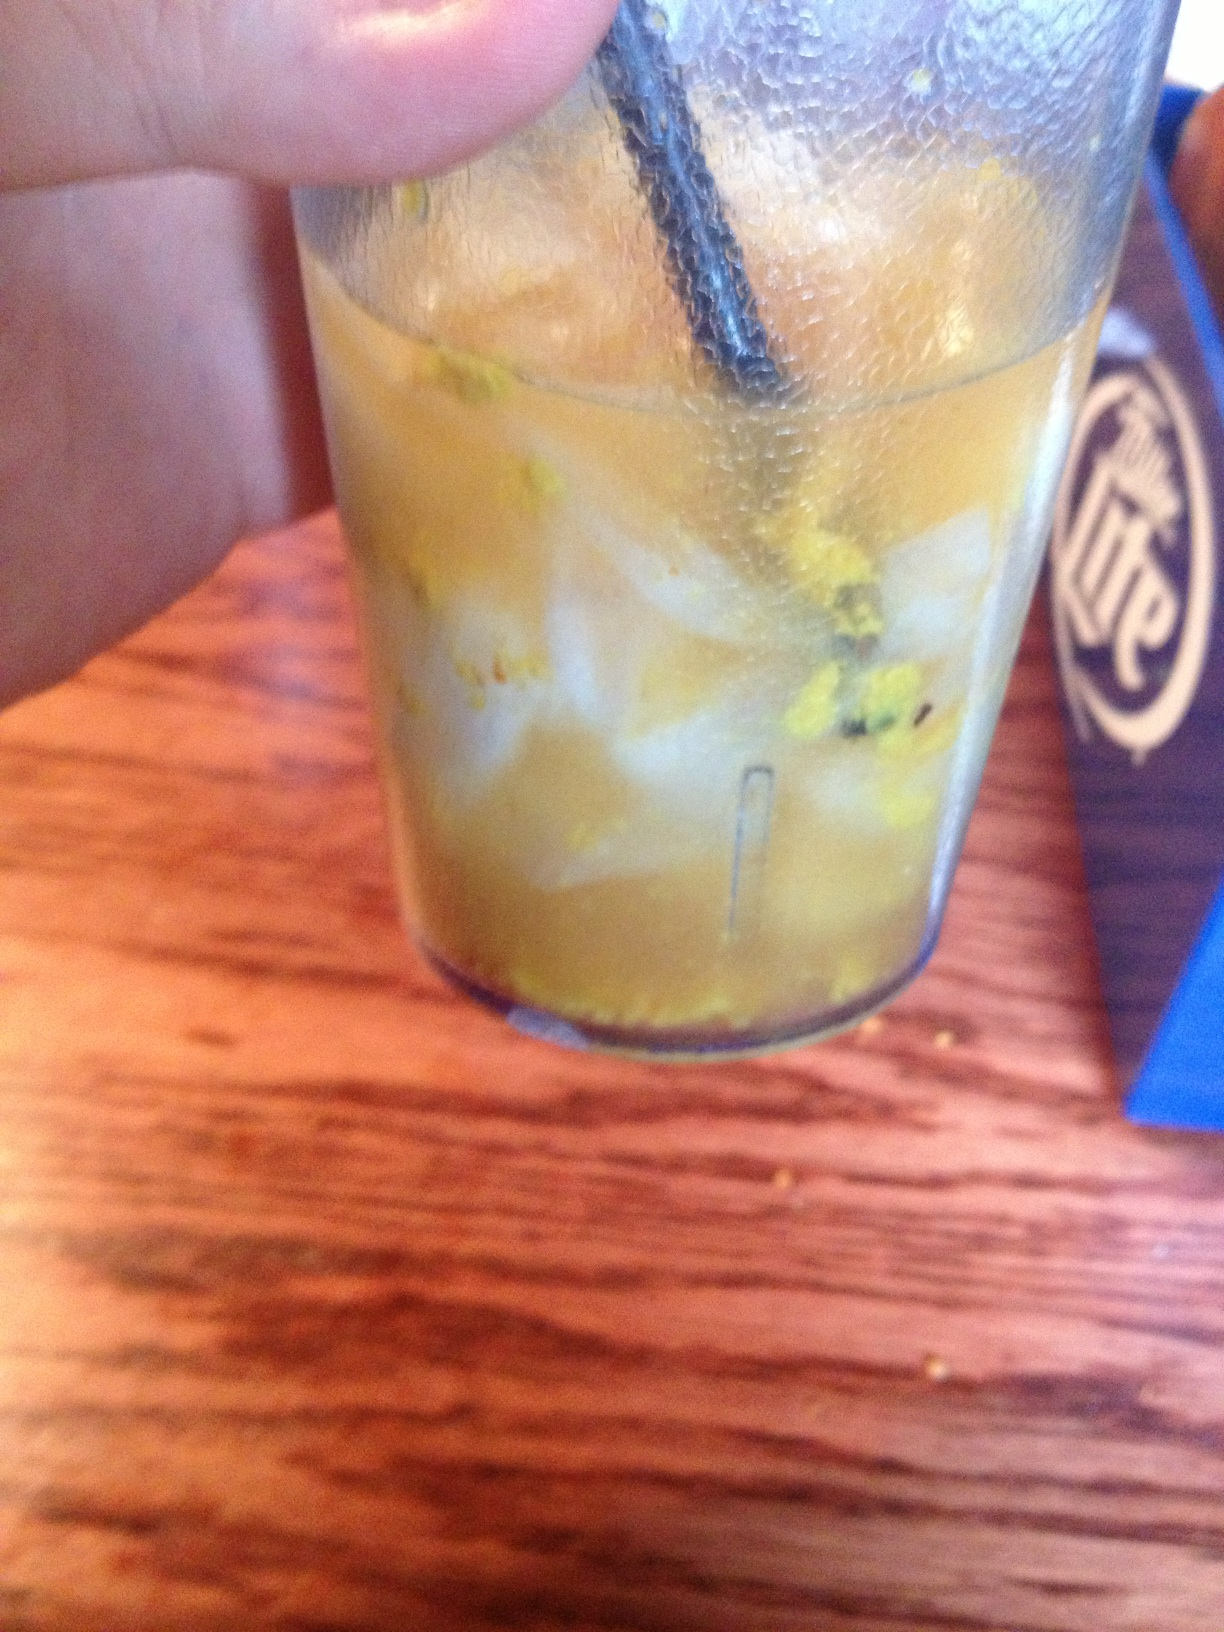This drink looks like it's part of a themed restaurant. Can you imagine a story behind this place? Absolutely! Welcome to 'The Alchemist's Tavern,' a hidden gem known only to those with a taste for the extraordinary and the magical. Every drink here is crafted with a touch of enchantment, blending traditional bartending skills with ancient alchemical secrets. This particular drink, 'The Solar Elixir,' is a house specialty, rumored to be brewed under the full moon with ingredients gathered from distant lands. A single sip is said to transport you to the forgotten realm of Eldoria, where mythical creatures roam and magic is woven into the very fabric of the land. 